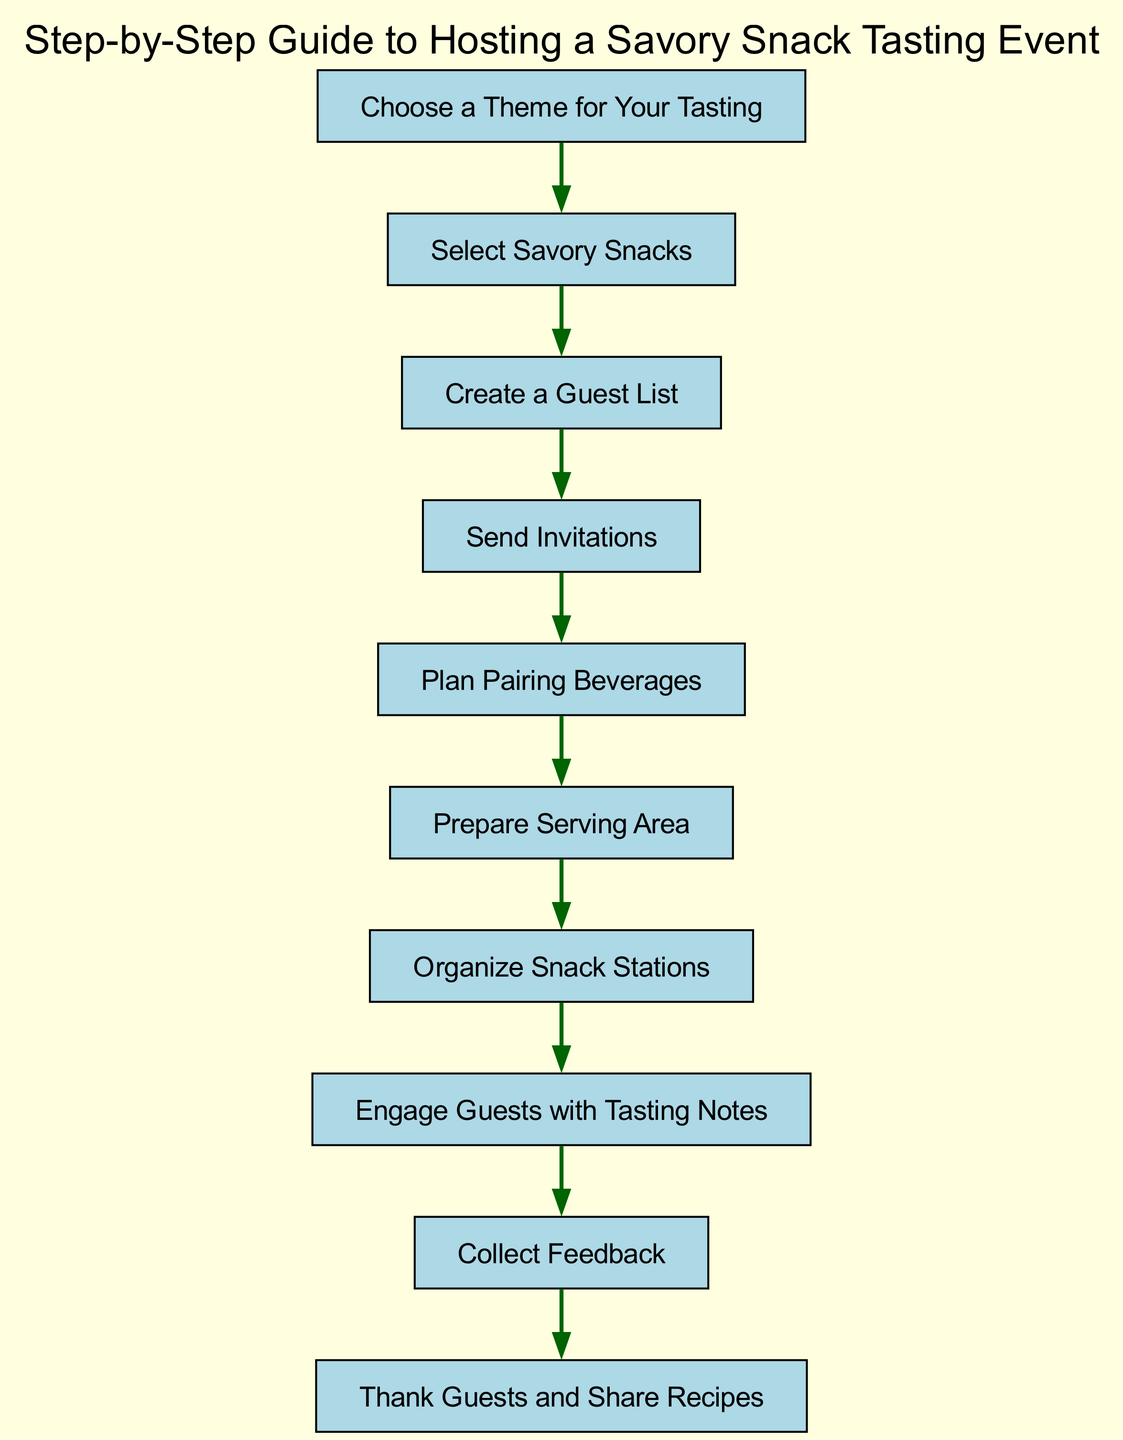What is the first step in the event planning? The first step is identified as "Choose a Theme for Your Tasting", which is the first node in the diagram.
Answer: Choose a Theme for Your Tasting How many steps are there in total? By counting the nodes from "step1" to "step10", there are ten steps represented in the flow chart.
Answer: 10 What is the last step in the process? The last step, indicated by the final node, is "Thank Guests and Share Recipes." It is the endpoint of the sequential flow.
Answer: Thank Guests and Share Recipes What follows the step "Select Savory Snacks"? The diagram shows a direct edge from "Select Savory Snacks" to "Create a Guest List", indicating that the next step is to create the guest list.
Answer: Create a Guest List Which step involves beverage planning? The step that involves beverage planning is "Plan Pairing Beverages", which is specifically stated in the flow chart.
Answer: Plan Pairing Beverages What step comes before "Engage Guests with Tasting Notes"? The step before "Engage Guests with Tasting Notes" is "Organize Snack Stations", as indicated by the flow of the diagram from one step to the next.
Answer: Organize Snack Stations How many edges are in the diagram? Each step is connected by a directed edge to the next, totaling nine edges from "step1" to "step10", which connects all ten steps.
Answer: 9 What is the relationship between "Send Invitations" and "Prepare Serving Area"? The flow chart indicates that "Send Invitations" leads to "Prepare Serving Area", establishing a direct sequential flow from one step to the next.
Answer: Send Invitations leads to Prepare Serving Area Which node is connected to the "Collect Feedback" step? The node connected to "Collect Feedback" is "Engage Guests with Tasting Notes", showing that feedback collection comes after guests are engaged with tasting notes.
Answer: Engage Guests with Tasting Notes 